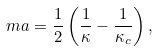Convert formula to latex. <formula><loc_0><loc_0><loc_500><loc_500>m a = \frac { 1 } { 2 } \left ( \frac { 1 } { \kappa } - \frac { 1 } { \kappa _ { c } } \right ) ,</formula> 